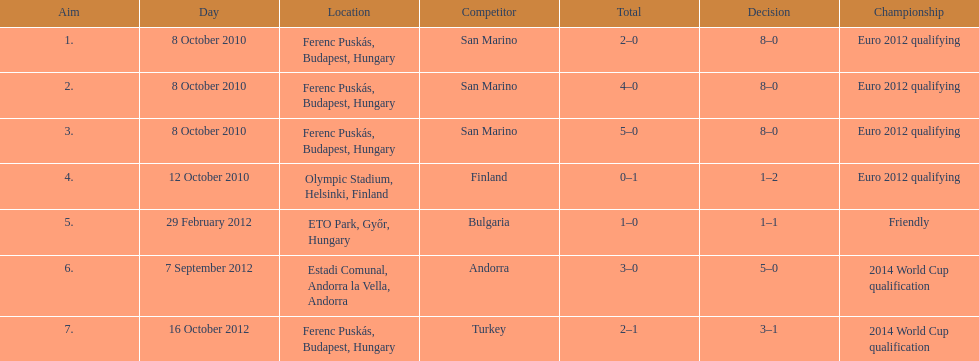How many consecutive games were goals were against san marino? 3. 